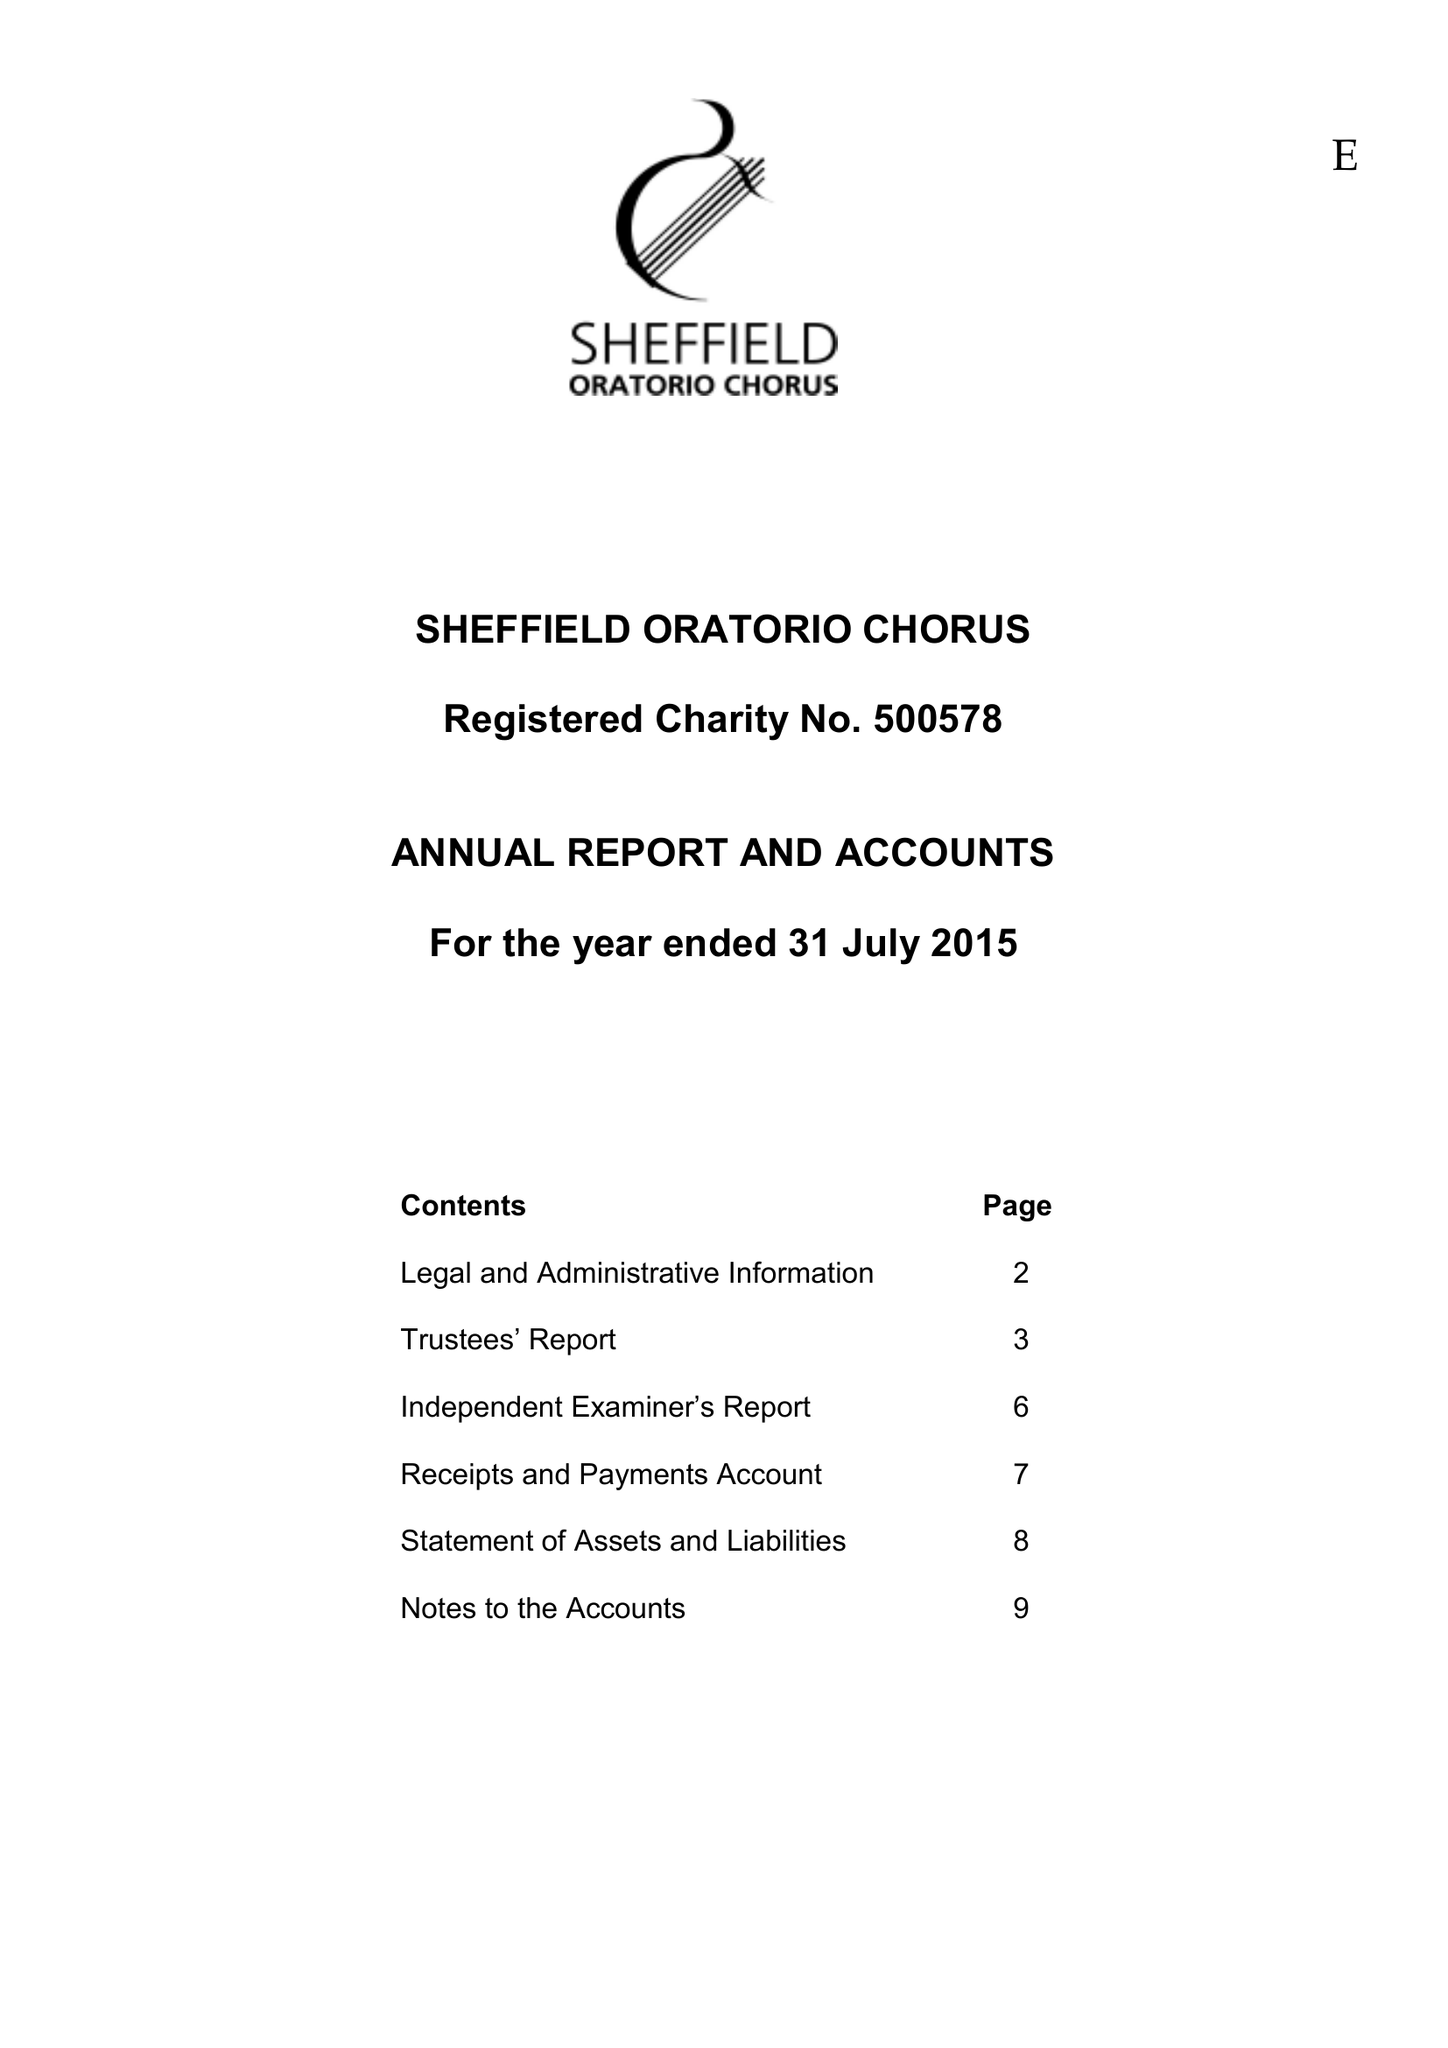What is the value for the spending_annually_in_british_pounds?
Answer the question using a single word or phrase. 43507.00 